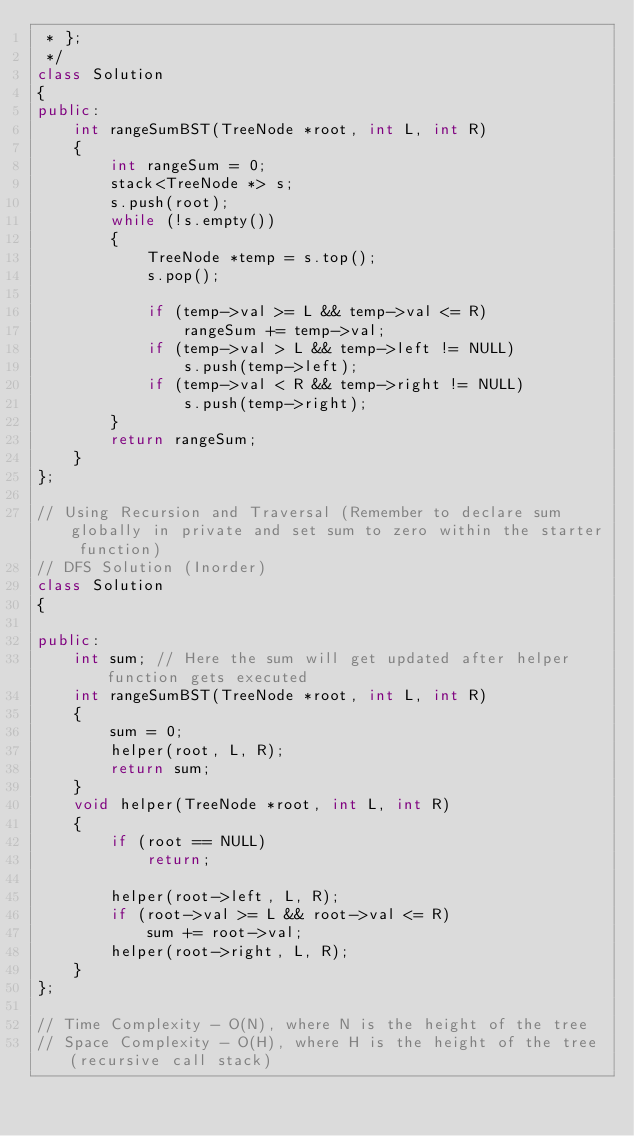<code> <loc_0><loc_0><loc_500><loc_500><_C++_> * };
 */
class Solution
{
public:
    int rangeSumBST(TreeNode *root, int L, int R)
    {
        int rangeSum = 0;
        stack<TreeNode *> s;
        s.push(root);
        while (!s.empty())
        {
            TreeNode *temp = s.top();
            s.pop();

            if (temp->val >= L && temp->val <= R)
                rangeSum += temp->val;
            if (temp->val > L && temp->left != NULL)
                s.push(temp->left);
            if (temp->val < R && temp->right != NULL)
                s.push(temp->right);
        }
        return rangeSum;
    }
};

// Using Recursion and Traversal (Remember to declare sum globally in private and set sum to zero within the starter function)
// DFS Solution (Inorder)
class Solution
{

public:
    int sum; // Here the sum will get updated after helper function gets executed
    int rangeSumBST(TreeNode *root, int L, int R)
    {
        sum = 0;
        helper(root, L, R);
        return sum;
    }
    void helper(TreeNode *root, int L, int R)
    {
        if (root == NULL)
            return;

        helper(root->left, L, R);
        if (root->val >= L && root->val <= R)
            sum += root->val;
        helper(root->right, L, R);
    }
};

// Time Complexity - O(N), where N is the height of the tree
// Space Complexity - O(H), where H is the height of the tree (recursive call stack)</code> 